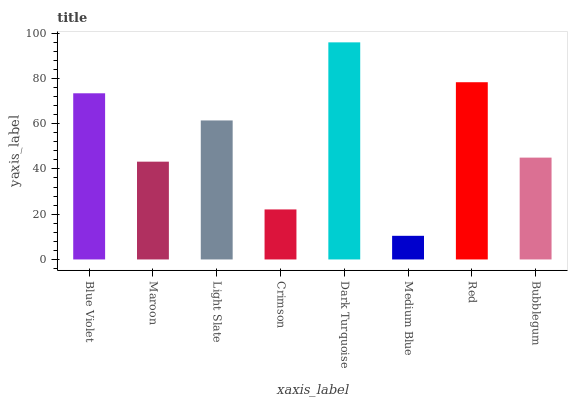Is Medium Blue the minimum?
Answer yes or no. Yes. Is Dark Turquoise the maximum?
Answer yes or no. Yes. Is Maroon the minimum?
Answer yes or no. No. Is Maroon the maximum?
Answer yes or no. No. Is Blue Violet greater than Maroon?
Answer yes or no. Yes. Is Maroon less than Blue Violet?
Answer yes or no. Yes. Is Maroon greater than Blue Violet?
Answer yes or no. No. Is Blue Violet less than Maroon?
Answer yes or no. No. Is Light Slate the high median?
Answer yes or no. Yes. Is Bubblegum the low median?
Answer yes or no. Yes. Is Blue Violet the high median?
Answer yes or no. No. Is Maroon the low median?
Answer yes or no. No. 